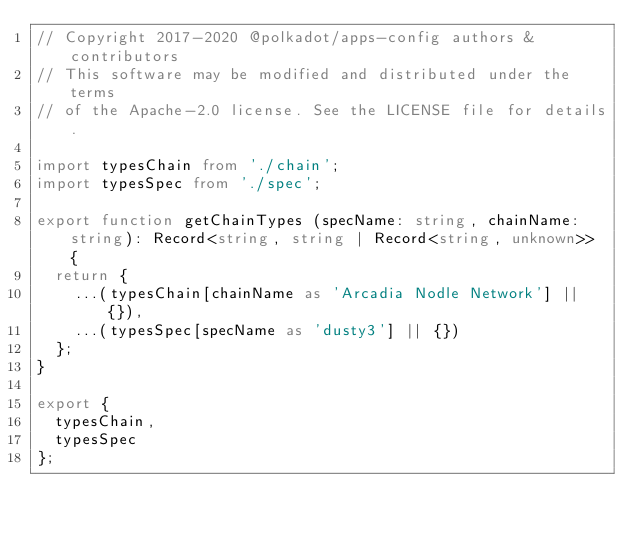<code> <loc_0><loc_0><loc_500><loc_500><_TypeScript_>// Copyright 2017-2020 @polkadot/apps-config authors & contributors
// This software may be modified and distributed under the terms
// of the Apache-2.0 license. See the LICENSE file for details.

import typesChain from './chain';
import typesSpec from './spec';

export function getChainTypes (specName: string, chainName: string): Record<string, string | Record<string, unknown>> {
  return {
    ...(typesChain[chainName as 'Arcadia Nodle Network'] || {}),
    ...(typesSpec[specName as 'dusty3'] || {})
  };
}

export {
  typesChain,
  typesSpec
};
</code> 